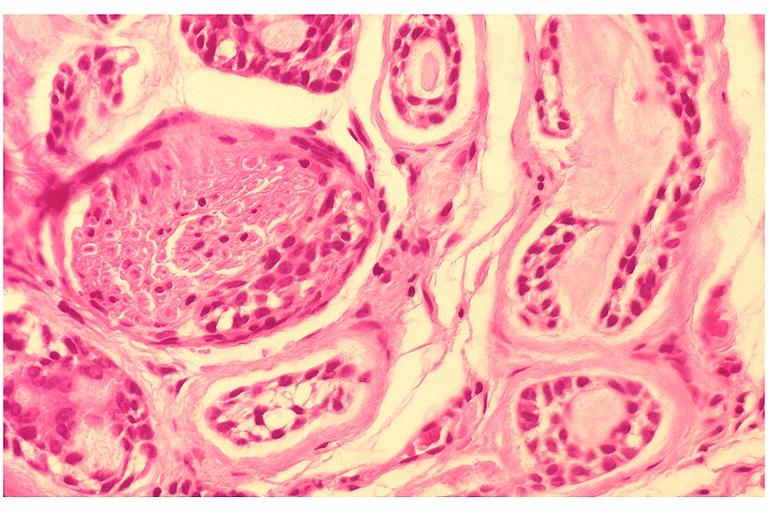does this person show adenoid cystic carcinoma?
Answer the question using a single word or phrase. No 